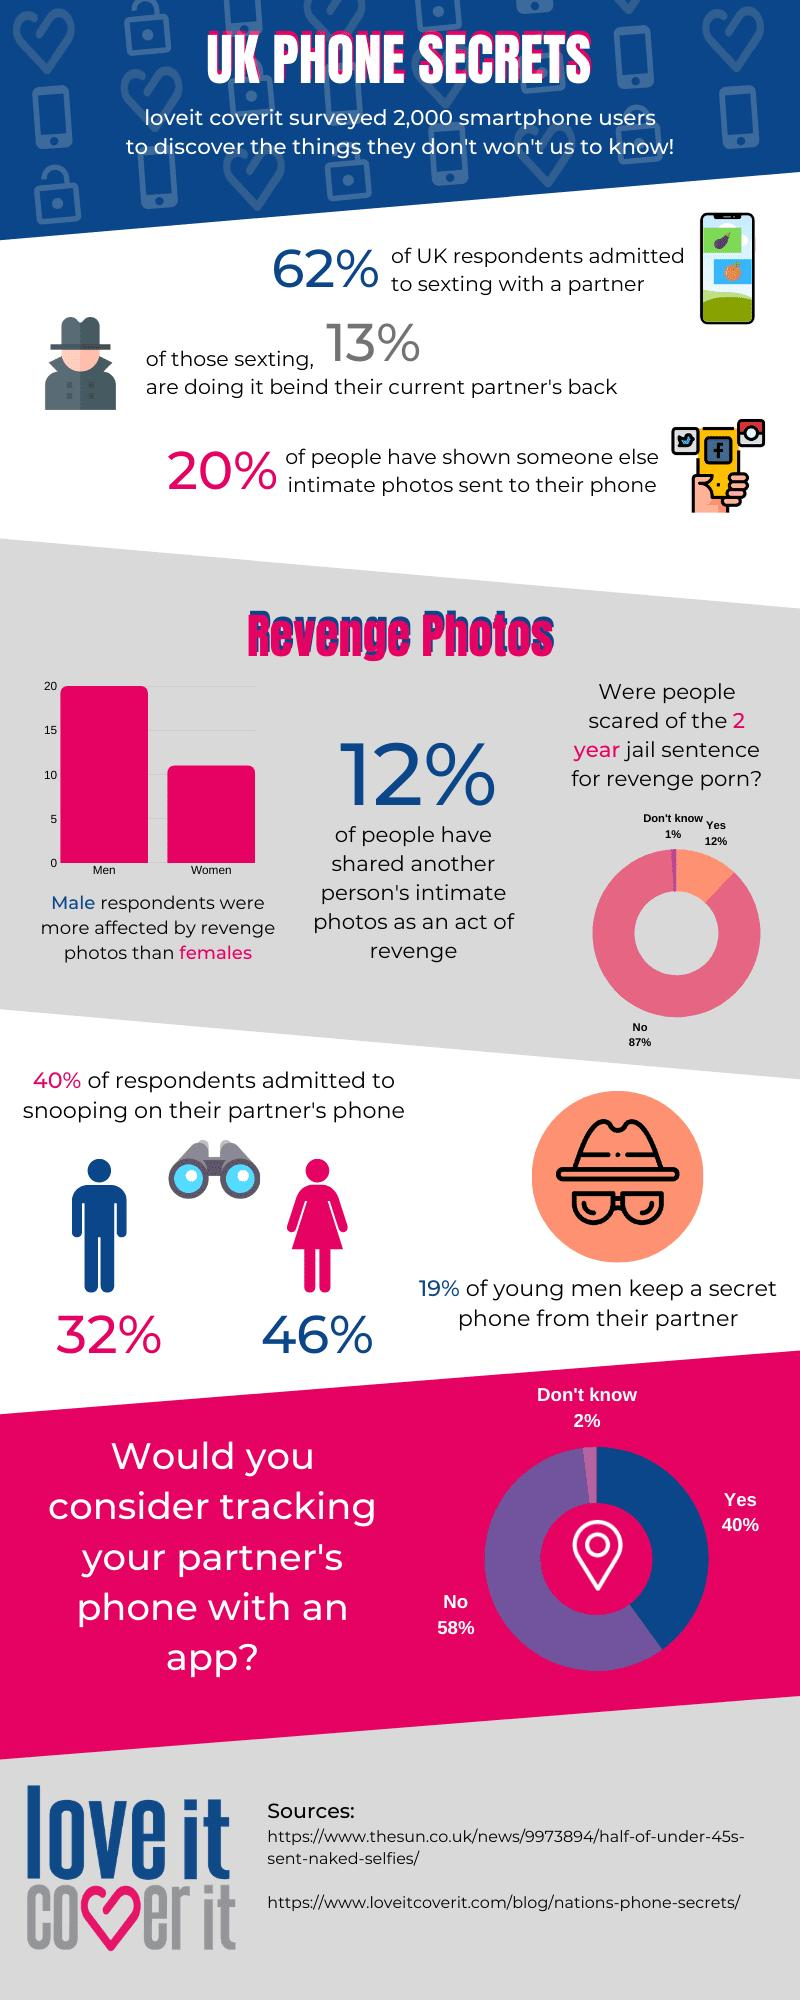Highlight a few significant elements in this photo. The color associated with the image of males in the given context is blue. In this study, 2000 respondents participated. According to the online survey, revenge photos affected men more than women by a margin of 50%. According to the data, only 2% of individuals are unsure whether they would use an app to track their partner's phone. Eighty-one percent of the respondents did not keep a secret phone from their partner, according to the survey. 